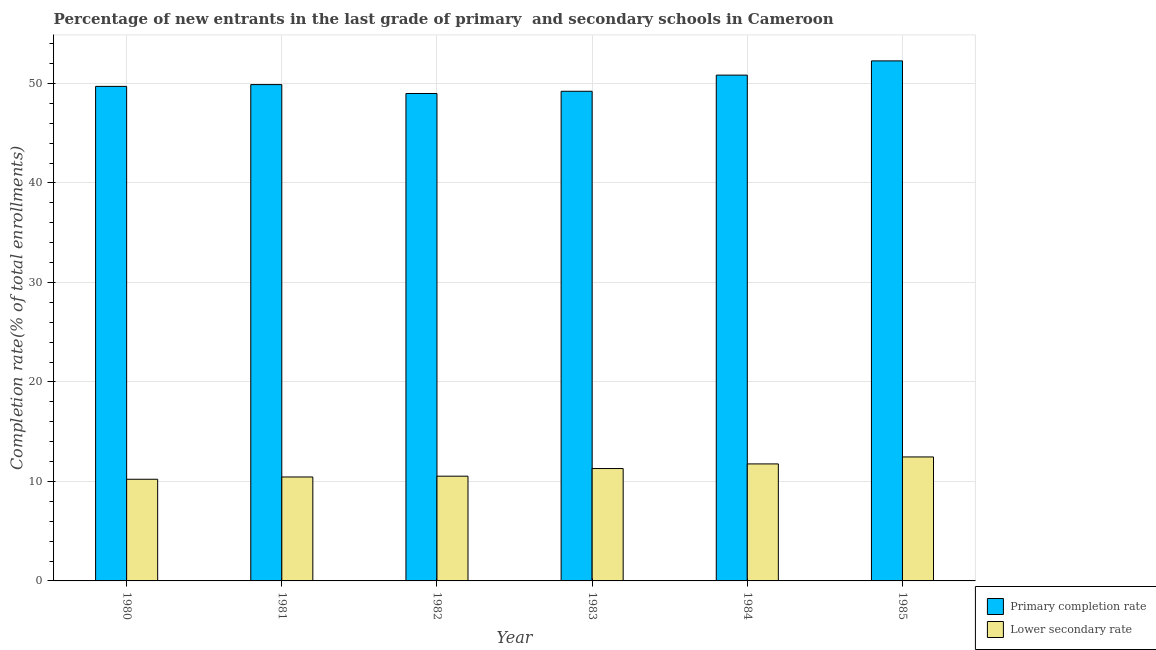How many different coloured bars are there?
Provide a short and direct response. 2. Are the number of bars on each tick of the X-axis equal?
Offer a terse response. Yes. How many bars are there on the 2nd tick from the left?
Provide a short and direct response. 2. How many bars are there on the 2nd tick from the right?
Keep it short and to the point. 2. What is the label of the 5th group of bars from the left?
Your answer should be compact. 1984. What is the completion rate in primary schools in 1983?
Ensure brevity in your answer.  49.21. Across all years, what is the maximum completion rate in primary schools?
Make the answer very short. 52.27. Across all years, what is the minimum completion rate in primary schools?
Offer a very short reply. 48.99. In which year was the completion rate in secondary schools minimum?
Ensure brevity in your answer.  1980. What is the total completion rate in secondary schools in the graph?
Provide a short and direct response. 66.7. What is the difference between the completion rate in primary schools in 1984 and that in 1985?
Provide a succinct answer. -1.43. What is the difference between the completion rate in primary schools in 1981 and the completion rate in secondary schools in 1983?
Give a very brief answer. 0.67. What is the average completion rate in secondary schools per year?
Give a very brief answer. 11.12. In the year 1980, what is the difference between the completion rate in primary schools and completion rate in secondary schools?
Provide a succinct answer. 0. What is the ratio of the completion rate in secondary schools in 1984 to that in 1985?
Offer a terse response. 0.94. What is the difference between the highest and the second highest completion rate in primary schools?
Make the answer very short. 1.43. What is the difference between the highest and the lowest completion rate in primary schools?
Your response must be concise. 3.28. What does the 2nd bar from the left in 1985 represents?
Give a very brief answer. Lower secondary rate. What does the 1st bar from the right in 1981 represents?
Offer a terse response. Lower secondary rate. How many years are there in the graph?
Ensure brevity in your answer.  6. What is the difference between two consecutive major ticks on the Y-axis?
Keep it short and to the point. 10. Does the graph contain any zero values?
Provide a succinct answer. No. What is the title of the graph?
Provide a short and direct response. Percentage of new entrants in the last grade of primary  and secondary schools in Cameroon. Does "Stunting" appear as one of the legend labels in the graph?
Ensure brevity in your answer.  No. What is the label or title of the X-axis?
Offer a terse response. Year. What is the label or title of the Y-axis?
Your answer should be very brief. Completion rate(% of total enrollments). What is the Completion rate(% of total enrollments) of Primary completion rate in 1980?
Provide a succinct answer. 49.7. What is the Completion rate(% of total enrollments) in Lower secondary rate in 1980?
Provide a succinct answer. 10.22. What is the Completion rate(% of total enrollments) in Primary completion rate in 1981?
Make the answer very short. 49.88. What is the Completion rate(% of total enrollments) of Lower secondary rate in 1981?
Keep it short and to the point. 10.45. What is the Completion rate(% of total enrollments) of Primary completion rate in 1982?
Make the answer very short. 48.99. What is the Completion rate(% of total enrollments) of Lower secondary rate in 1982?
Your response must be concise. 10.53. What is the Completion rate(% of total enrollments) in Primary completion rate in 1983?
Make the answer very short. 49.21. What is the Completion rate(% of total enrollments) of Lower secondary rate in 1983?
Make the answer very short. 11.29. What is the Completion rate(% of total enrollments) of Primary completion rate in 1984?
Keep it short and to the point. 50.83. What is the Completion rate(% of total enrollments) in Lower secondary rate in 1984?
Provide a short and direct response. 11.76. What is the Completion rate(% of total enrollments) in Primary completion rate in 1985?
Offer a terse response. 52.27. What is the Completion rate(% of total enrollments) in Lower secondary rate in 1985?
Offer a very short reply. 12.46. Across all years, what is the maximum Completion rate(% of total enrollments) of Primary completion rate?
Offer a very short reply. 52.27. Across all years, what is the maximum Completion rate(% of total enrollments) of Lower secondary rate?
Give a very brief answer. 12.46. Across all years, what is the minimum Completion rate(% of total enrollments) in Primary completion rate?
Your answer should be very brief. 48.99. Across all years, what is the minimum Completion rate(% of total enrollments) in Lower secondary rate?
Ensure brevity in your answer.  10.22. What is the total Completion rate(% of total enrollments) of Primary completion rate in the graph?
Provide a succinct answer. 300.88. What is the total Completion rate(% of total enrollments) of Lower secondary rate in the graph?
Provide a short and direct response. 66.7. What is the difference between the Completion rate(% of total enrollments) of Primary completion rate in 1980 and that in 1981?
Offer a terse response. -0.18. What is the difference between the Completion rate(% of total enrollments) in Lower secondary rate in 1980 and that in 1981?
Give a very brief answer. -0.23. What is the difference between the Completion rate(% of total enrollments) in Primary completion rate in 1980 and that in 1982?
Give a very brief answer. 0.71. What is the difference between the Completion rate(% of total enrollments) in Lower secondary rate in 1980 and that in 1982?
Offer a very short reply. -0.31. What is the difference between the Completion rate(% of total enrollments) of Primary completion rate in 1980 and that in 1983?
Keep it short and to the point. 0.49. What is the difference between the Completion rate(% of total enrollments) of Lower secondary rate in 1980 and that in 1983?
Offer a very short reply. -1.08. What is the difference between the Completion rate(% of total enrollments) in Primary completion rate in 1980 and that in 1984?
Your response must be concise. -1.13. What is the difference between the Completion rate(% of total enrollments) in Lower secondary rate in 1980 and that in 1984?
Give a very brief answer. -1.54. What is the difference between the Completion rate(% of total enrollments) in Primary completion rate in 1980 and that in 1985?
Keep it short and to the point. -2.56. What is the difference between the Completion rate(% of total enrollments) of Lower secondary rate in 1980 and that in 1985?
Ensure brevity in your answer.  -2.24. What is the difference between the Completion rate(% of total enrollments) of Primary completion rate in 1981 and that in 1982?
Give a very brief answer. 0.89. What is the difference between the Completion rate(% of total enrollments) of Lower secondary rate in 1981 and that in 1982?
Offer a terse response. -0.08. What is the difference between the Completion rate(% of total enrollments) of Primary completion rate in 1981 and that in 1983?
Offer a terse response. 0.67. What is the difference between the Completion rate(% of total enrollments) in Lower secondary rate in 1981 and that in 1983?
Make the answer very short. -0.85. What is the difference between the Completion rate(% of total enrollments) of Primary completion rate in 1981 and that in 1984?
Your response must be concise. -0.95. What is the difference between the Completion rate(% of total enrollments) in Lower secondary rate in 1981 and that in 1984?
Ensure brevity in your answer.  -1.31. What is the difference between the Completion rate(% of total enrollments) of Primary completion rate in 1981 and that in 1985?
Make the answer very short. -2.38. What is the difference between the Completion rate(% of total enrollments) of Lower secondary rate in 1981 and that in 1985?
Your response must be concise. -2.01. What is the difference between the Completion rate(% of total enrollments) in Primary completion rate in 1982 and that in 1983?
Offer a terse response. -0.22. What is the difference between the Completion rate(% of total enrollments) of Lower secondary rate in 1982 and that in 1983?
Provide a succinct answer. -0.77. What is the difference between the Completion rate(% of total enrollments) in Primary completion rate in 1982 and that in 1984?
Your answer should be compact. -1.85. What is the difference between the Completion rate(% of total enrollments) of Lower secondary rate in 1982 and that in 1984?
Ensure brevity in your answer.  -1.23. What is the difference between the Completion rate(% of total enrollments) in Primary completion rate in 1982 and that in 1985?
Provide a succinct answer. -3.28. What is the difference between the Completion rate(% of total enrollments) in Lower secondary rate in 1982 and that in 1985?
Provide a short and direct response. -1.93. What is the difference between the Completion rate(% of total enrollments) in Primary completion rate in 1983 and that in 1984?
Offer a very short reply. -1.62. What is the difference between the Completion rate(% of total enrollments) in Lower secondary rate in 1983 and that in 1984?
Offer a very short reply. -0.47. What is the difference between the Completion rate(% of total enrollments) in Primary completion rate in 1983 and that in 1985?
Provide a short and direct response. -3.06. What is the difference between the Completion rate(% of total enrollments) in Lower secondary rate in 1983 and that in 1985?
Offer a very short reply. -1.17. What is the difference between the Completion rate(% of total enrollments) of Primary completion rate in 1984 and that in 1985?
Your answer should be compact. -1.43. What is the difference between the Completion rate(% of total enrollments) of Lower secondary rate in 1984 and that in 1985?
Provide a succinct answer. -0.7. What is the difference between the Completion rate(% of total enrollments) in Primary completion rate in 1980 and the Completion rate(% of total enrollments) in Lower secondary rate in 1981?
Provide a succinct answer. 39.26. What is the difference between the Completion rate(% of total enrollments) of Primary completion rate in 1980 and the Completion rate(% of total enrollments) of Lower secondary rate in 1982?
Provide a short and direct response. 39.18. What is the difference between the Completion rate(% of total enrollments) of Primary completion rate in 1980 and the Completion rate(% of total enrollments) of Lower secondary rate in 1983?
Give a very brief answer. 38.41. What is the difference between the Completion rate(% of total enrollments) of Primary completion rate in 1980 and the Completion rate(% of total enrollments) of Lower secondary rate in 1984?
Provide a short and direct response. 37.94. What is the difference between the Completion rate(% of total enrollments) of Primary completion rate in 1980 and the Completion rate(% of total enrollments) of Lower secondary rate in 1985?
Provide a succinct answer. 37.24. What is the difference between the Completion rate(% of total enrollments) of Primary completion rate in 1981 and the Completion rate(% of total enrollments) of Lower secondary rate in 1982?
Offer a very short reply. 39.36. What is the difference between the Completion rate(% of total enrollments) of Primary completion rate in 1981 and the Completion rate(% of total enrollments) of Lower secondary rate in 1983?
Your answer should be very brief. 38.59. What is the difference between the Completion rate(% of total enrollments) in Primary completion rate in 1981 and the Completion rate(% of total enrollments) in Lower secondary rate in 1984?
Offer a very short reply. 38.12. What is the difference between the Completion rate(% of total enrollments) in Primary completion rate in 1981 and the Completion rate(% of total enrollments) in Lower secondary rate in 1985?
Offer a terse response. 37.42. What is the difference between the Completion rate(% of total enrollments) in Primary completion rate in 1982 and the Completion rate(% of total enrollments) in Lower secondary rate in 1983?
Offer a very short reply. 37.69. What is the difference between the Completion rate(% of total enrollments) of Primary completion rate in 1982 and the Completion rate(% of total enrollments) of Lower secondary rate in 1984?
Provide a short and direct response. 37.23. What is the difference between the Completion rate(% of total enrollments) in Primary completion rate in 1982 and the Completion rate(% of total enrollments) in Lower secondary rate in 1985?
Offer a terse response. 36.53. What is the difference between the Completion rate(% of total enrollments) in Primary completion rate in 1983 and the Completion rate(% of total enrollments) in Lower secondary rate in 1984?
Offer a terse response. 37.45. What is the difference between the Completion rate(% of total enrollments) in Primary completion rate in 1983 and the Completion rate(% of total enrollments) in Lower secondary rate in 1985?
Provide a succinct answer. 36.75. What is the difference between the Completion rate(% of total enrollments) in Primary completion rate in 1984 and the Completion rate(% of total enrollments) in Lower secondary rate in 1985?
Make the answer very short. 38.37. What is the average Completion rate(% of total enrollments) in Primary completion rate per year?
Offer a terse response. 50.15. What is the average Completion rate(% of total enrollments) of Lower secondary rate per year?
Provide a succinct answer. 11.12. In the year 1980, what is the difference between the Completion rate(% of total enrollments) in Primary completion rate and Completion rate(% of total enrollments) in Lower secondary rate?
Ensure brevity in your answer.  39.48. In the year 1981, what is the difference between the Completion rate(% of total enrollments) in Primary completion rate and Completion rate(% of total enrollments) in Lower secondary rate?
Offer a terse response. 39.43. In the year 1982, what is the difference between the Completion rate(% of total enrollments) in Primary completion rate and Completion rate(% of total enrollments) in Lower secondary rate?
Your response must be concise. 38.46. In the year 1983, what is the difference between the Completion rate(% of total enrollments) in Primary completion rate and Completion rate(% of total enrollments) in Lower secondary rate?
Provide a succinct answer. 37.92. In the year 1984, what is the difference between the Completion rate(% of total enrollments) of Primary completion rate and Completion rate(% of total enrollments) of Lower secondary rate?
Give a very brief answer. 39.07. In the year 1985, what is the difference between the Completion rate(% of total enrollments) of Primary completion rate and Completion rate(% of total enrollments) of Lower secondary rate?
Provide a short and direct response. 39.81. What is the ratio of the Completion rate(% of total enrollments) in Lower secondary rate in 1980 to that in 1981?
Provide a succinct answer. 0.98. What is the ratio of the Completion rate(% of total enrollments) of Primary completion rate in 1980 to that in 1982?
Provide a short and direct response. 1.01. What is the ratio of the Completion rate(% of total enrollments) of Lower secondary rate in 1980 to that in 1982?
Offer a terse response. 0.97. What is the ratio of the Completion rate(% of total enrollments) in Lower secondary rate in 1980 to that in 1983?
Your response must be concise. 0.9. What is the ratio of the Completion rate(% of total enrollments) of Primary completion rate in 1980 to that in 1984?
Make the answer very short. 0.98. What is the ratio of the Completion rate(% of total enrollments) of Lower secondary rate in 1980 to that in 1984?
Make the answer very short. 0.87. What is the ratio of the Completion rate(% of total enrollments) of Primary completion rate in 1980 to that in 1985?
Make the answer very short. 0.95. What is the ratio of the Completion rate(% of total enrollments) in Lower secondary rate in 1980 to that in 1985?
Offer a terse response. 0.82. What is the ratio of the Completion rate(% of total enrollments) of Primary completion rate in 1981 to that in 1982?
Keep it short and to the point. 1.02. What is the ratio of the Completion rate(% of total enrollments) of Lower secondary rate in 1981 to that in 1982?
Your answer should be compact. 0.99. What is the ratio of the Completion rate(% of total enrollments) in Primary completion rate in 1981 to that in 1983?
Offer a terse response. 1.01. What is the ratio of the Completion rate(% of total enrollments) in Lower secondary rate in 1981 to that in 1983?
Provide a short and direct response. 0.93. What is the ratio of the Completion rate(% of total enrollments) in Primary completion rate in 1981 to that in 1984?
Keep it short and to the point. 0.98. What is the ratio of the Completion rate(% of total enrollments) of Lower secondary rate in 1981 to that in 1984?
Keep it short and to the point. 0.89. What is the ratio of the Completion rate(% of total enrollments) of Primary completion rate in 1981 to that in 1985?
Make the answer very short. 0.95. What is the ratio of the Completion rate(% of total enrollments) of Lower secondary rate in 1981 to that in 1985?
Offer a terse response. 0.84. What is the ratio of the Completion rate(% of total enrollments) of Primary completion rate in 1982 to that in 1983?
Give a very brief answer. 1. What is the ratio of the Completion rate(% of total enrollments) in Lower secondary rate in 1982 to that in 1983?
Your answer should be very brief. 0.93. What is the ratio of the Completion rate(% of total enrollments) in Primary completion rate in 1982 to that in 1984?
Make the answer very short. 0.96. What is the ratio of the Completion rate(% of total enrollments) of Lower secondary rate in 1982 to that in 1984?
Your answer should be very brief. 0.9. What is the ratio of the Completion rate(% of total enrollments) of Primary completion rate in 1982 to that in 1985?
Ensure brevity in your answer.  0.94. What is the ratio of the Completion rate(% of total enrollments) in Lower secondary rate in 1982 to that in 1985?
Provide a short and direct response. 0.84. What is the ratio of the Completion rate(% of total enrollments) in Primary completion rate in 1983 to that in 1984?
Your response must be concise. 0.97. What is the ratio of the Completion rate(% of total enrollments) in Lower secondary rate in 1983 to that in 1984?
Give a very brief answer. 0.96. What is the ratio of the Completion rate(% of total enrollments) in Primary completion rate in 1983 to that in 1985?
Provide a short and direct response. 0.94. What is the ratio of the Completion rate(% of total enrollments) of Lower secondary rate in 1983 to that in 1985?
Offer a very short reply. 0.91. What is the ratio of the Completion rate(% of total enrollments) in Primary completion rate in 1984 to that in 1985?
Provide a succinct answer. 0.97. What is the ratio of the Completion rate(% of total enrollments) of Lower secondary rate in 1984 to that in 1985?
Offer a terse response. 0.94. What is the difference between the highest and the second highest Completion rate(% of total enrollments) in Primary completion rate?
Offer a very short reply. 1.43. What is the difference between the highest and the lowest Completion rate(% of total enrollments) of Primary completion rate?
Keep it short and to the point. 3.28. What is the difference between the highest and the lowest Completion rate(% of total enrollments) of Lower secondary rate?
Offer a very short reply. 2.24. 